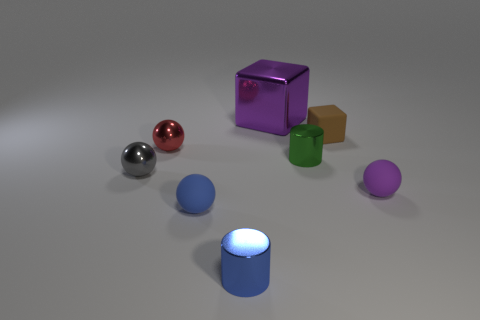Is the tiny blue object that is in front of the tiny blue matte ball made of the same material as the block right of the large purple metallic thing?
Provide a succinct answer. No. What number of small objects are blue shiny cylinders or rubber cubes?
Keep it short and to the point. 2. There is a tiny purple object that is the same material as the brown block; what is its shape?
Provide a succinct answer. Sphere. Are there fewer tiny blue matte balls left of the gray metallic ball than brown matte blocks?
Provide a succinct answer. Yes. Is the small gray thing the same shape as the purple rubber thing?
Offer a terse response. Yes. What number of metallic things are either tiny gray spheres or tiny cylinders?
Your answer should be compact. 3. Is there a green object of the same size as the purple ball?
Your answer should be compact. Yes. There is another rubber object that is the same color as the large object; what shape is it?
Provide a succinct answer. Sphere. How many cyan matte cubes are the same size as the green cylinder?
Your answer should be very brief. 0. Does the sphere that is on the right side of the big block have the same size as the shiny cylinder behind the gray shiny object?
Keep it short and to the point. Yes. 